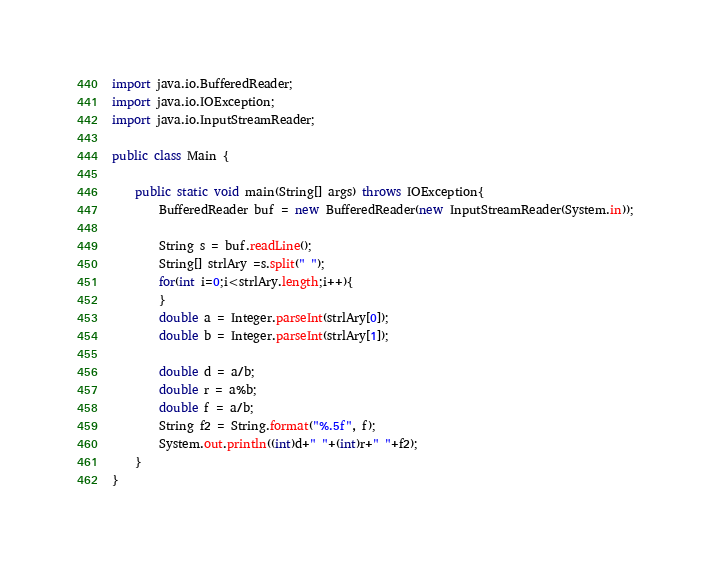Convert code to text. <code><loc_0><loc_0><loc_500><loc_500><_Java_>import java.io.BufferedReader;
import java.io.IOException;
import java.io.InputStreamReader;

public class Main {

	public static void main(String[] args) throws IOException{
		BufferedReader buf = new BufferedReader(new InputStreamReader(System.in));
		
		String s = buf.readLine();
    	String[] strlAry =s.split(" ");
    	for(int i=0;i<strlAry.length;i++){
   	    }
   	    double a = Integer.parseInt(strlAry[0]);
   	    double b = Integer.parseInt(strlAry[1]);

   	    double d = a/b;
   	    double r = a%b;
   	    double f = a/b;
   	    String f2 = String.format("%.5f", f);
   	    System.out.println((int)d+" "+(int)r+" "+f2);
 	}
}</code> 